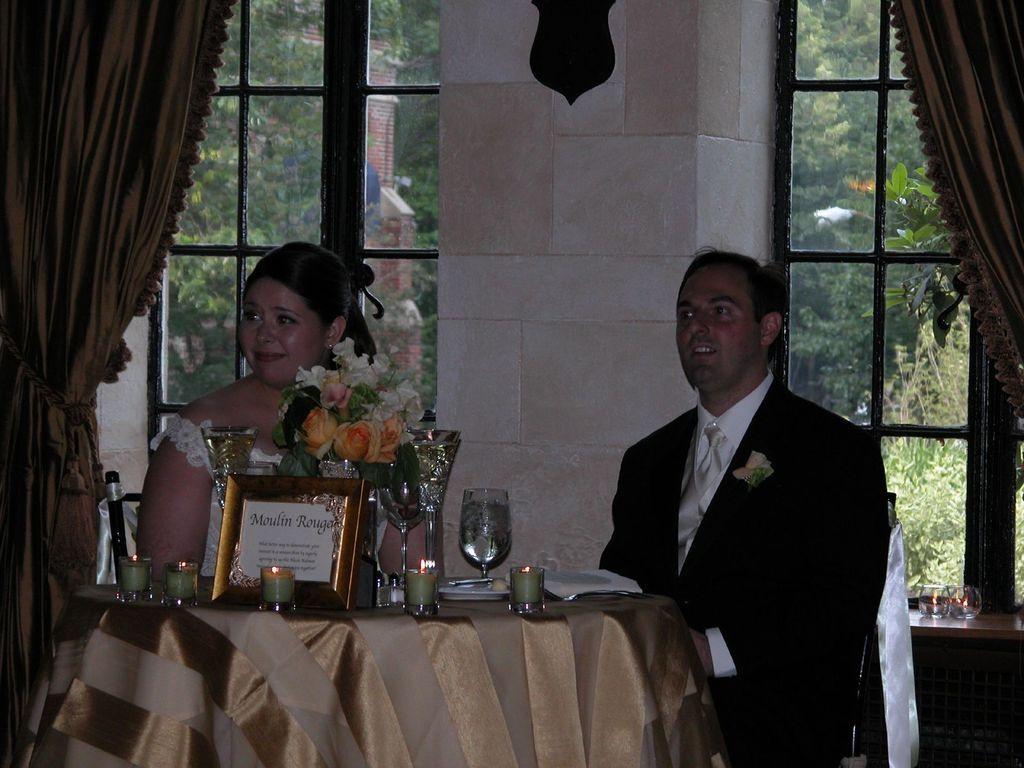Could you give a brief overview of what you see in this image? This woman and this man are sitting on a chair. On this table there are candles, flowers and glasses. From this window we can able to see trees. This is curtain. 